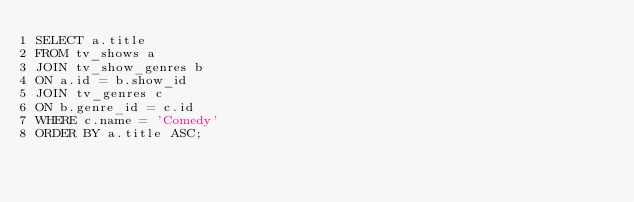<code> <loc_0><loc_0><loc_500><loc_500><_SQL_>SELECT a.title
FROM tv_shows a
JOIN tv_show_genres b
ON a.id = b.show_id
JOIN tv_genres c
ON b.genre_id = c.id
WHERE c.name = 'Comedy'
ORDER BY a.title ASC;
</code> 